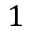Convert formula to latex. <formula><loc_0><loc_0><loc_500><loc_500>1</formula> 